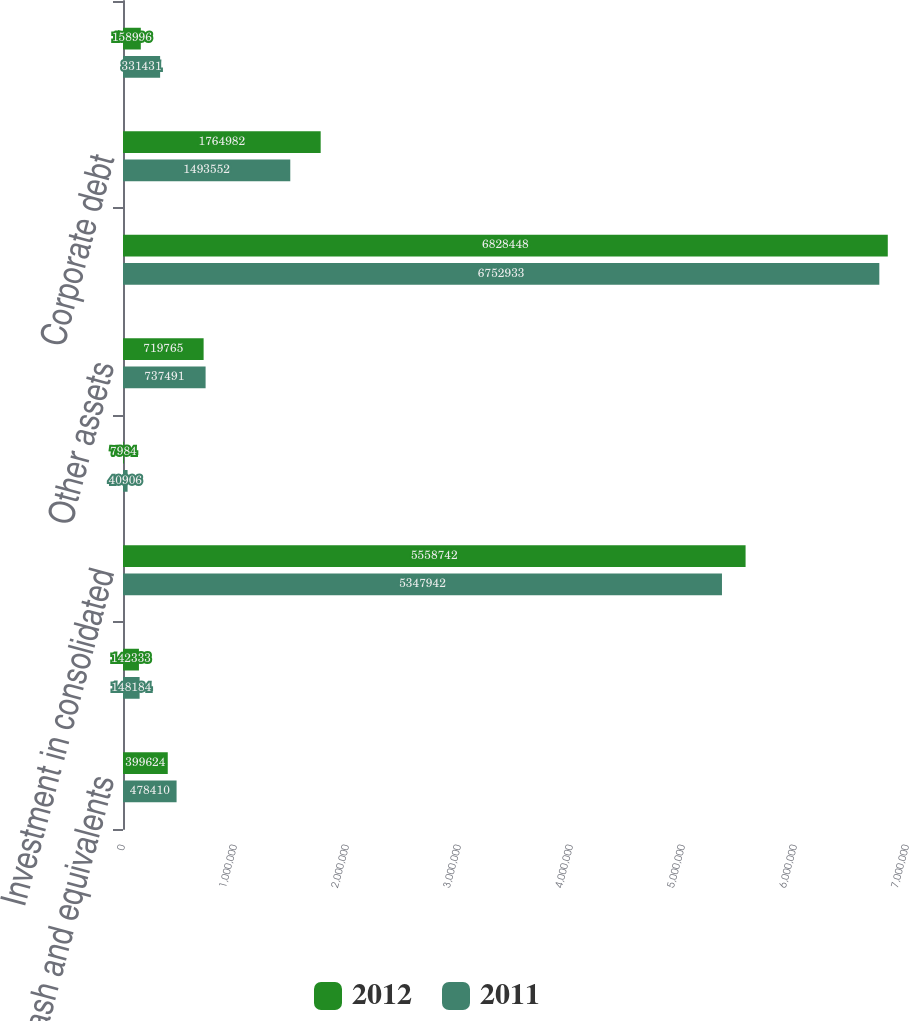Convert chart. <chart><loc_0><loc_0><loc_500><loc_500><stacked_bar_chart><ecel><fcel>Cash and equivalents<fcel>Property and equipment net<fcel>Investment in consolidated<fcel>Receivable from subsidiaries<fcel>Other assets<fcel>Total assets<fcel>Corporate debt<fcel>Other liabilities<nl><fcel>2012<fcel>399624<fcel>142333<fcel>5.55874e+06<fcel>7984<fcel>719765<fcel>6.82845e+06<fcel>1.76498e+06<fcel>158996<nl><fcel>2011<fcel>478410<fcel>148184<fcel>5.34794e+06<fcel>40906<fcel>737491<fcel>6.75293e+06<fcel>1.49355e+06<fcel>331431<nl></chart> 